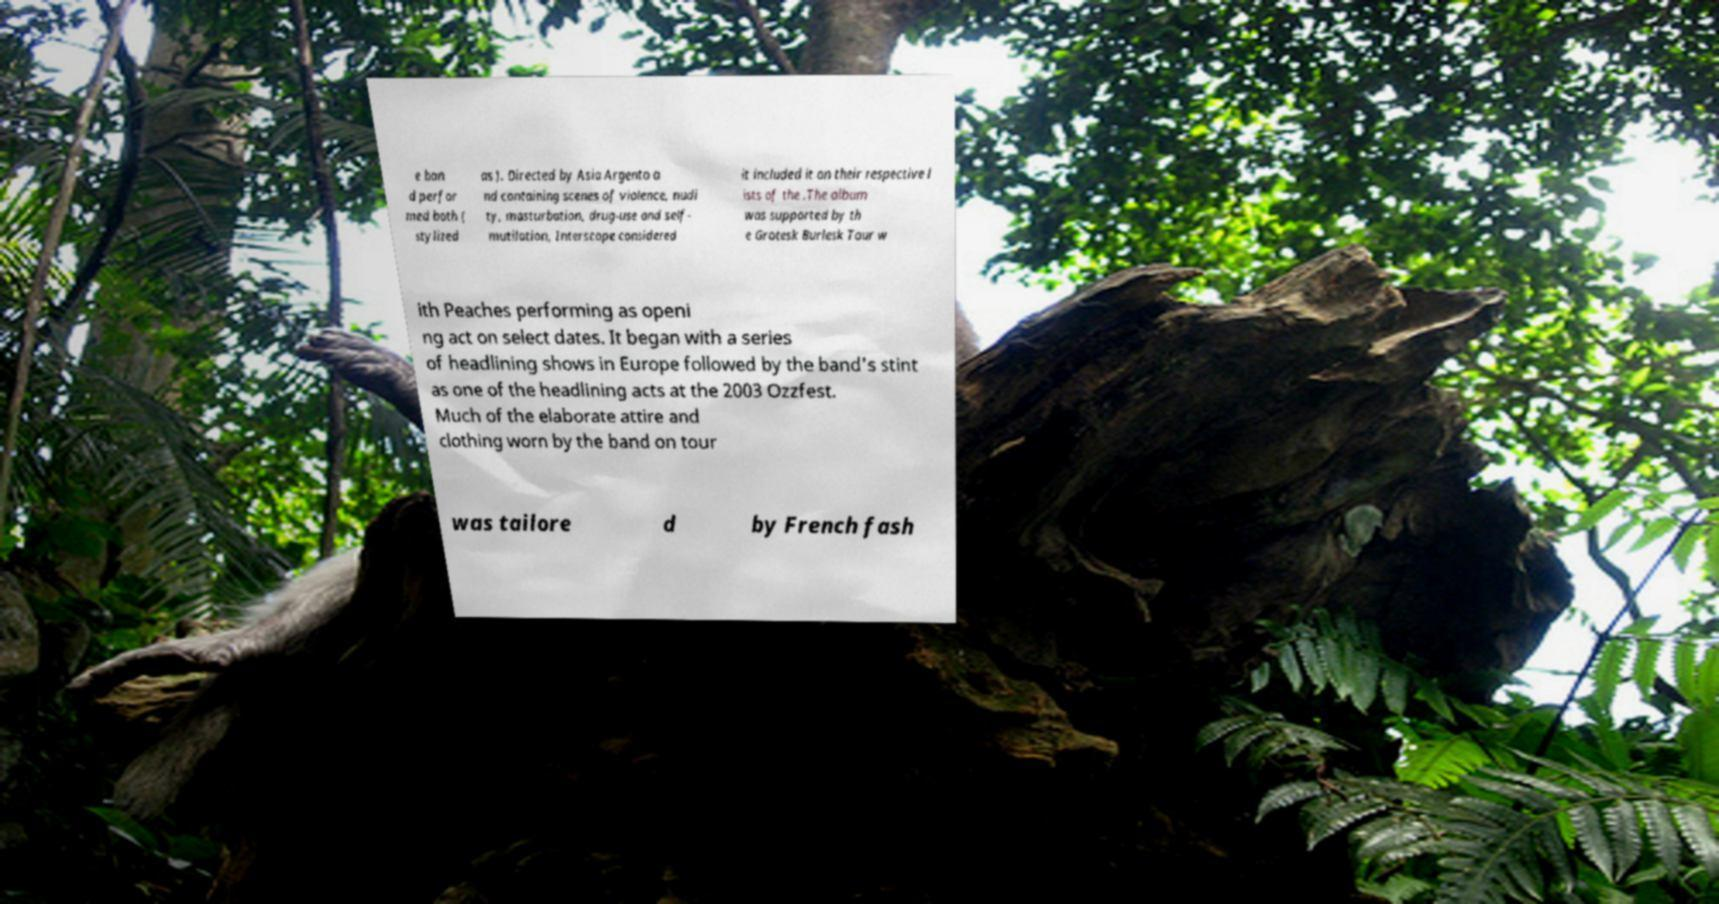What messages or text are displayed in this image? I need them in a readable, typed format. e ban d perfor med both ( stylized as ). Directed by Asia Argento a nd containing scenes of violence, nudi ty, masturbation, drug-use and self- mutilation, Interscope considered it included it on their respective l ists of the .The album was supported by th e Grotesk Burlesk Tour w ith Peaches performing as openi ng act on select dates. It began with a series of headlining shows in Europe followed by the band's stint as one of the headlining acts at the 2003 Ozzfest. Much of the elaborate attire and clothing worn by the band on tour was tailore d by French fash 